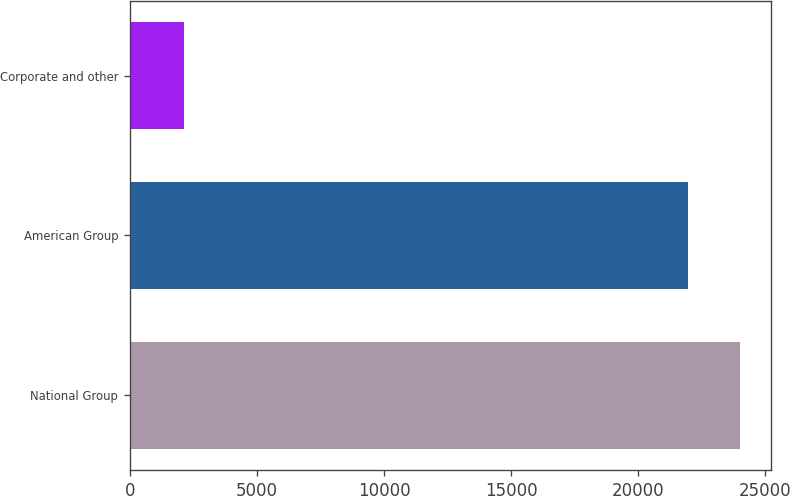Convert chart to OTSL. <chart><loc_0><loc_0><loc_500><loc_500><bar_chart><fcel>National Group<fcel>American Group<fcel>Corporate and other<nl><fcel>24003.4<fcel>21959<fcel>2137<nl></chart> 